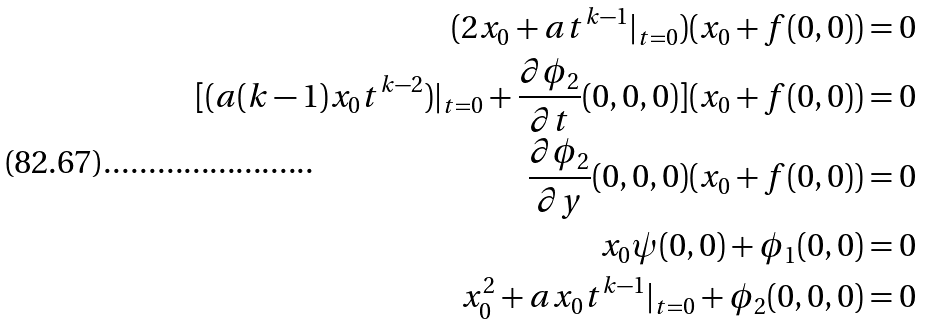<formula> <loc_0><loc_0><loc_500><loc_500>( 2 x _ { 0 } + a t ^ { k - 1 } | _ { t = 0 } ) ( x _ { 0 } + f ( 0 , 0 ) ) = 0 \\ [ ( a ( k - 1 ) x _ { 0 } t ^ { k - 2 } ) | _ { t = 0 } + \frac { \partial \phi _ { 2 } } { \partial t } ( 0 , 0 , 0 ) ] ( x _ { 0 } + f ( 0 , 0 ) ) = 0 \\ \frac { \partial \phi _ { 2 } } { \partial y } ( 0 , 0 , 0 ) ( x _ { 0 } + f ( 0 , 0 ) ) = 0 \\ x _ { 0 } \psi ( 0 , 0 ) + \phi _ { 1 } ( 0 , 0 ) = 0 \\ x _ { 0 } ^ { 2 } + a x _ { 0 } t ^ { k - 1 } | _ { t = 0 } + \phi _ { 2 } ( 0 , 0 , 0 ) = 0</formula> 